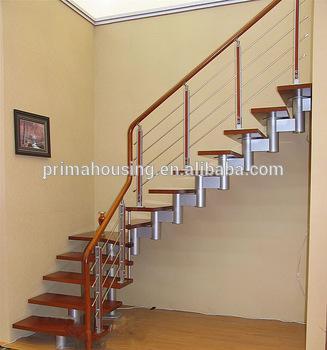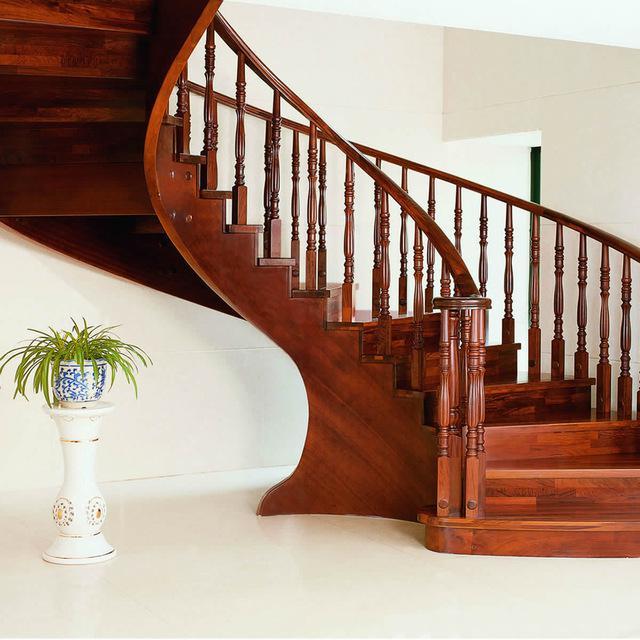The first image is the image on the left, the second image is the image on the right. Considering the images on both sides, is "The left image shows a staircase with a closed-in bottom and the edges of the stairs visible from the side, and the staircase ascends to the right, then turns leftward." valid? Answer yes or no. No. The first image is the image on the left, the second image is the image on the right. Given the left and right images, does the statement "In at least one image there is  white and light brown stair with a light brown rail and painted white poles." hold true? Answer yes or no. No. 